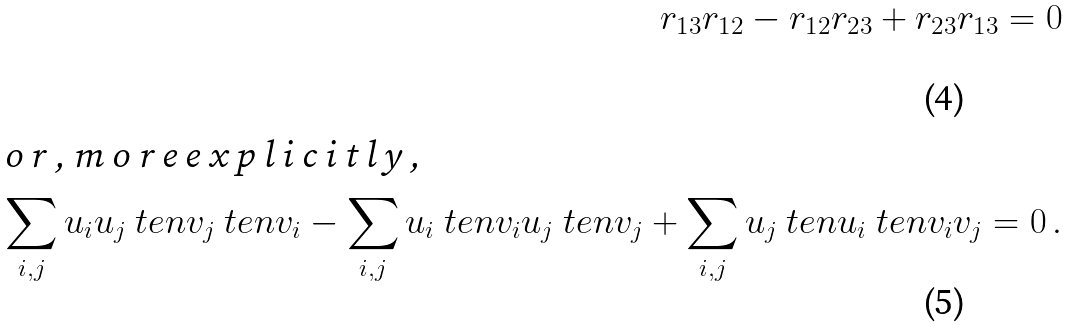Convert formula to latex. <formula><loc_0><loc_0><loc_500><loc_500>r _ { 1 3 } r _ { 1 2 } - r _ { 1 2 } r _ { 2 3 } + r _ { 2 3 } r _ { 1 3 } = 0 \\ \intertext { o r , m o r e e x p l i c i t l y , } \sum _ { i , j } u _ { i } u _ { j } \ t e n v _ { j } \ t e n v _ { i } - \sum _ { i , j } u _ { i } \ t e n v _ { i } u _ { j } \ t e n v _ { j } + \sum _ { i , j } u _ { j } \ t e n u _ { i } \ t e n v _ { i } v _ { j } = 0 \, .</formula> 